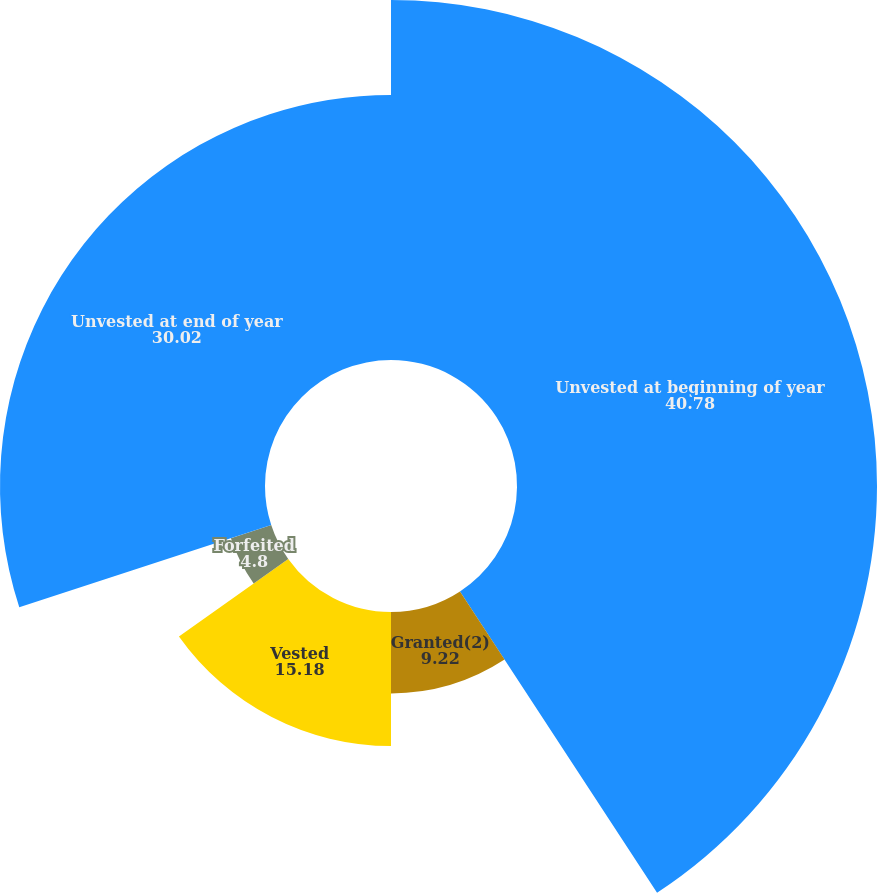Convert chart. <chart><loc_0><loc_0><loc_500><loc_500><pie_chart><fcel>Unvested at beginning of year<fcel>Granted(2)<fcel>Vested<fcel>Forfeited<fcel>Unvested at end of year<nl><fcel>40.78%<fcel>9.22%<fcel>15.18%<fcel>4.8%<fcel>30.02%<nl></chart> 